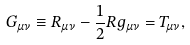Convert formula to latex. <formula><loc_0><loc_0><loc_500><loc_500>G _ { \mu \nu } \equiv R _ { \mu \nu } - \frac { 1 } { 2 } R g _ { \mu \nu } = T _ { \mu \nu } ,</formula> 